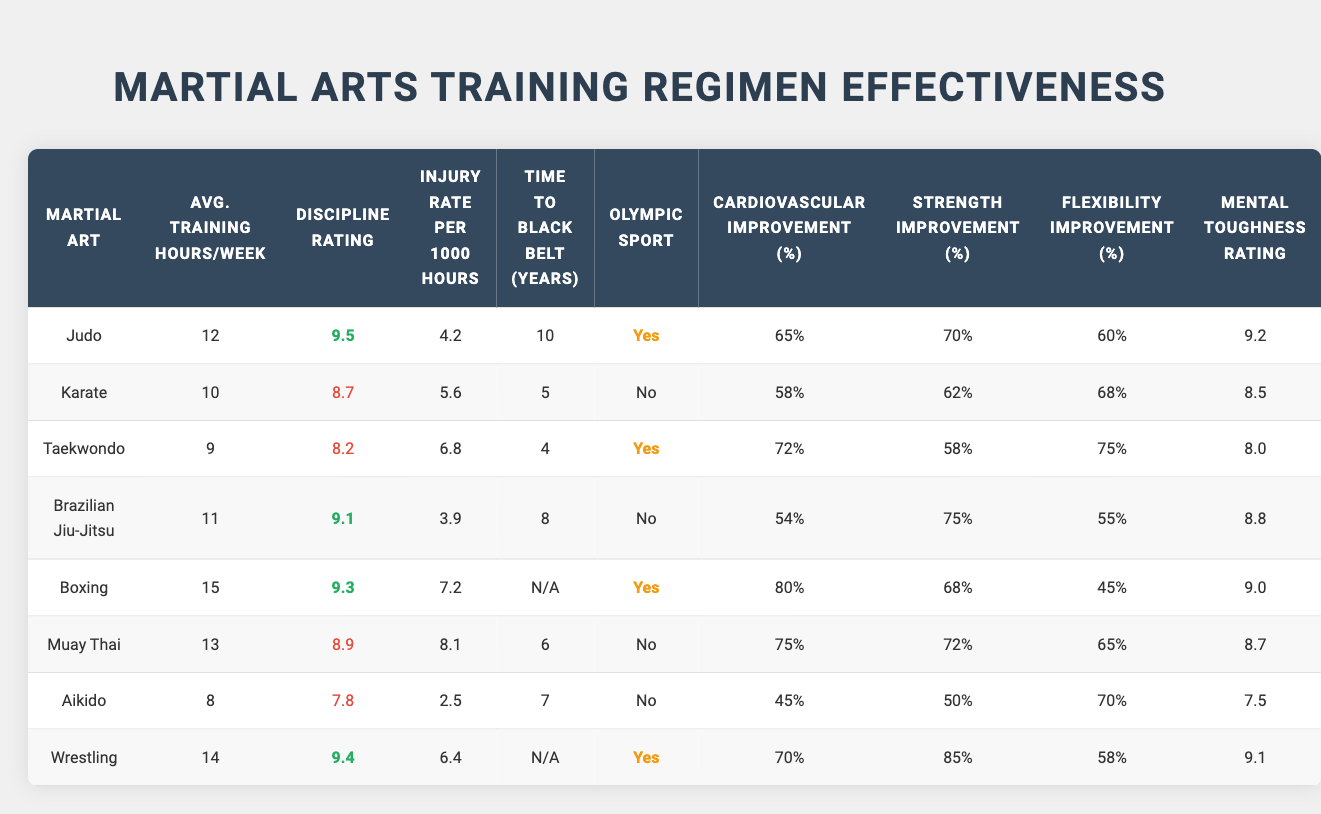What is the average training hours per week for Boxing? In the table, the average training hours per week for Boxing is listed directly. It shows a value of 15 hours per week.
Answer: 15 How many martial arts disciplines have a discipline rating of 9.0 or higher? By reviewing the discipline ratings in the table, Judo, Brazilian Jiu-Jitsu, Boxing, and Wrestling have ratings of 9.0 or higher. In total, there are 5 disciplines meeting this criterion.
Answer: 5 Which martial art has the highest flexibility improvement percentage? Looking at the flexibility improvement percentages, Muay Thai has the highest percentage at 75%.
Answer: 75% What is the injury rate for Aikido compared to Rugby? Aikido has an injury rate of 2.5 per 1000 hours, while Rugby is not listed in the table; therefore, this comparison cannot be made directly. However, Aikido has a lower injury rate than most listed disciplines.
Answer: Not applicable Is Taekwondo an Olympic sport? The table indicates whether each martial art is an Olympic sport. For Taekwondo, the entry shows 'No', meaning it is not an Olympic sport.
Answer: No Which martial arts discipline requires the longest time to achieve a black belt? From the time to black belt data, Judo requires 10 years, which is the longest among the listed disciplines.
Answer: 10 years What is the average strength improvement percentage across all martial arts in the table? To find the average, add up all the strength improvement percentages (70 + 62 + 58 + 75 + 68 + 72 + 50 + 85) = 540, and divide by the number of disciplines (8). The average strength improvement percentage is calculated to be 67.5%.
Answer: 67.5% Which martial art has the lowest injury rate? The injury rates show that Aikido has the lowest injury rate at 2.5 per 1000 hours, which is lower than all other disciplines.
Answer: 2.5 How does the cardiovascular improvement percentage for Karate compare to that of Brazilian Jiu-Jitsu? Karate has a cardiovascular improvement percentage of 58%, while Brazilian Jiu-Jitsu has 54%. Karate has a higher percentage by 4%.
Answer: Karate is better by 4% Is the discipline rating of Muay Thai higher than that of Aikido? By checking the discipline ratings, Muay Thai is rated 8.9 while Aikido is rated 7.8. Since 8.9 is greater than 7.8, Muay Thai has a higher discipline rating.
Answer: Yes What is the difference between the average training hours per week for Judo and Taekwondo? Judo has 12 hours per week and Taekwondo has 9 hours per week. The difference is calculated as 12 - 9 = 3 hours.
Answer: 3 hours 